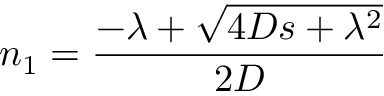<formula> <loc_0><loc_0><loc_500><loc_500>n _ { 1 } = \frac { - \lambda + \sqrt { 4 D s + \lambda ^ { 2 } } } { 2 D }</formula> 